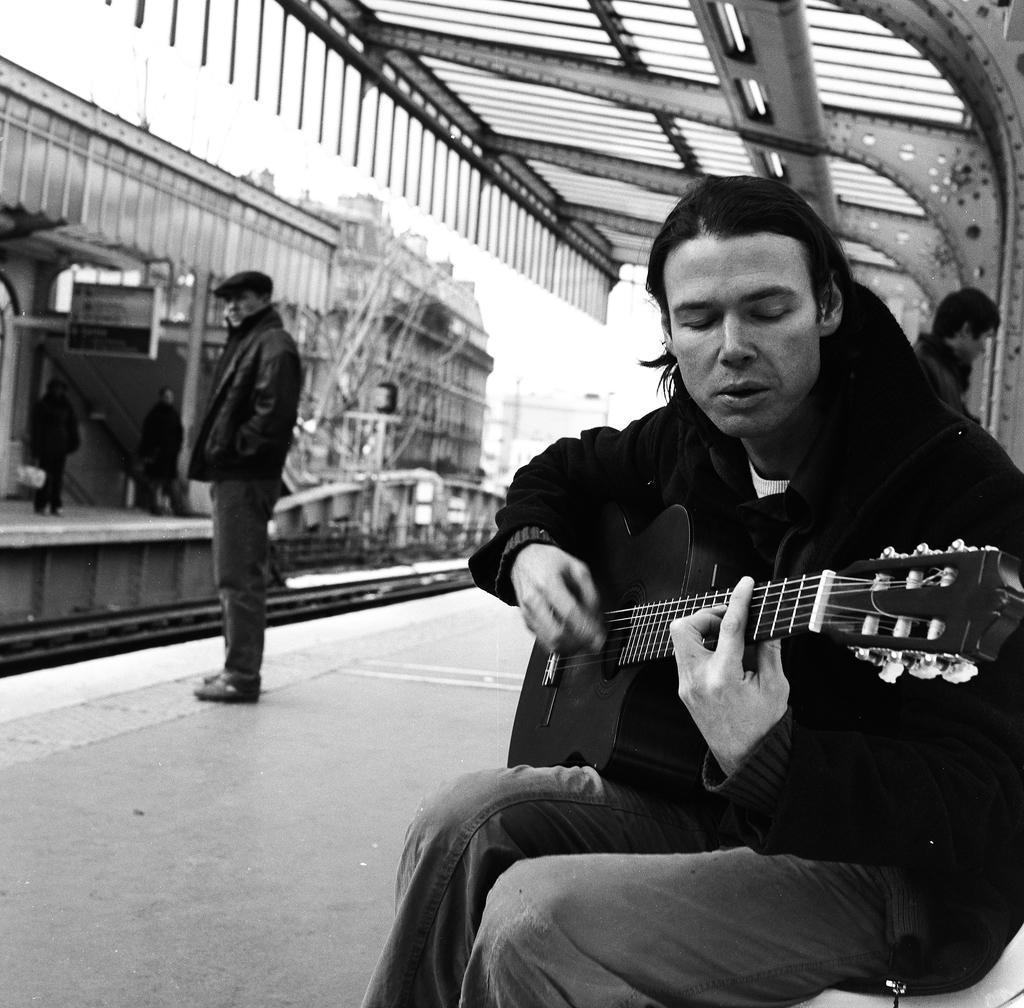In one or two sentences, can you explain what this image depicts? In this image I can see people where a man is sitting and holding a guitar and rest all are standing. 